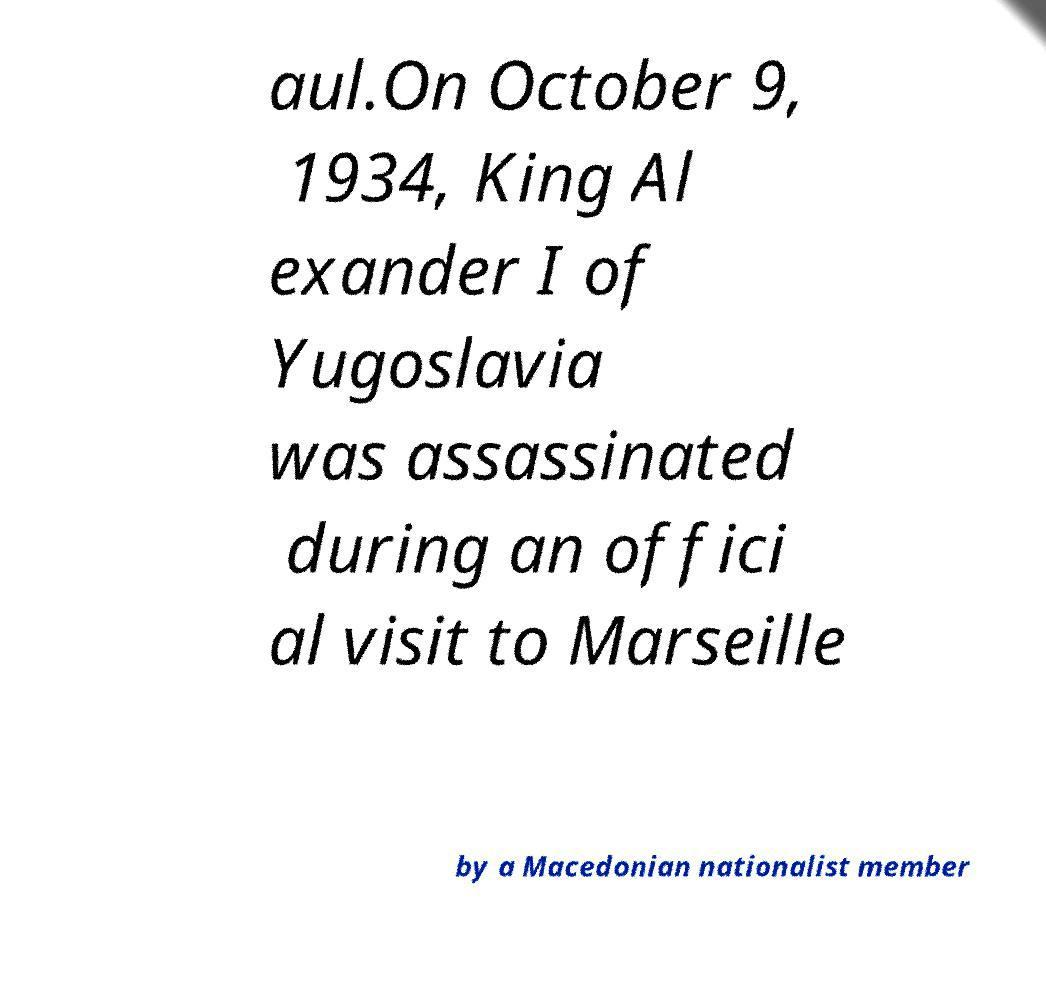Please read and relay the text visible in this image. What does it say? aul.On October 9, 1934, King Al exander I of Yugoslavia was assassinated during an offici al visit to Marseille by a Macedonian nationalist member 